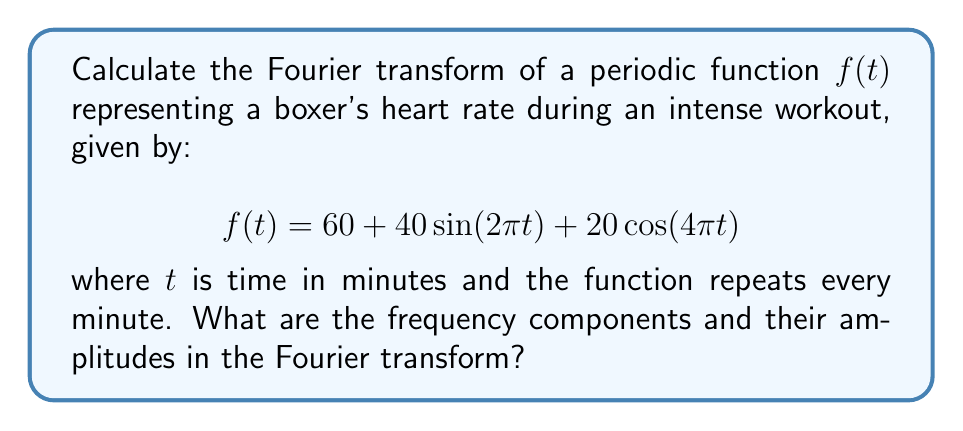Could you help me with this problem? To calculate the Fourier transform of this periodic function, we'll follow these steps:

1) First, note that the function is already expressed as a sum of sinusoidal components, which makes our task easier.

2) The Fourier transform of a periodic function results in a series of impulses at the frequencies present in the function. The amplitude of each impulse is proportional to the coefficient of the corresponding sinusoidal component.

3) Let's identify the components:
   - Constant term: 60
   - $\sin(2\pi t)$ term with amplitude 40
   - $\cos(4\pi t)$ term with amplitude 20

4) The Fourier transform $F(\omega)$ will have the following components:
   - An impulse at $\omega = 0$ (DC component) with amplitude 60
   - Impulses at $\omega = \pm 2\pi$ (1 cycle per minute) with amplitude 20 each (half of 40)
   - Impulses at $\omega = \pm 4\pi$ (2 cycles per minute) with amplitude 10 each (half of 20)

5) Mathematically, this can be expressed as:

   $$F(\omega) = 60\delta(\omega) + 20[\delta(\omega+2\pi) + \delta(\omega-2\pi)] + 10[\delta(\omega+4\pi) + \delta(\omega-4\pi)]$$

   where $\delta(\omega)$ is the Dirac delta function.

6) The amplitudes are halved for the sinusoidal components because the energy is split between positive and negative frequencies in the Fourier transform.
Answer: $F(\omega) = 60\delta(\omega) + 20[\delta(\omega+2\pi) + \delta(\omega-2\pi)] + 10[\delta(\omega+4\pi) + \delta(\omega-4\pi)]$ 